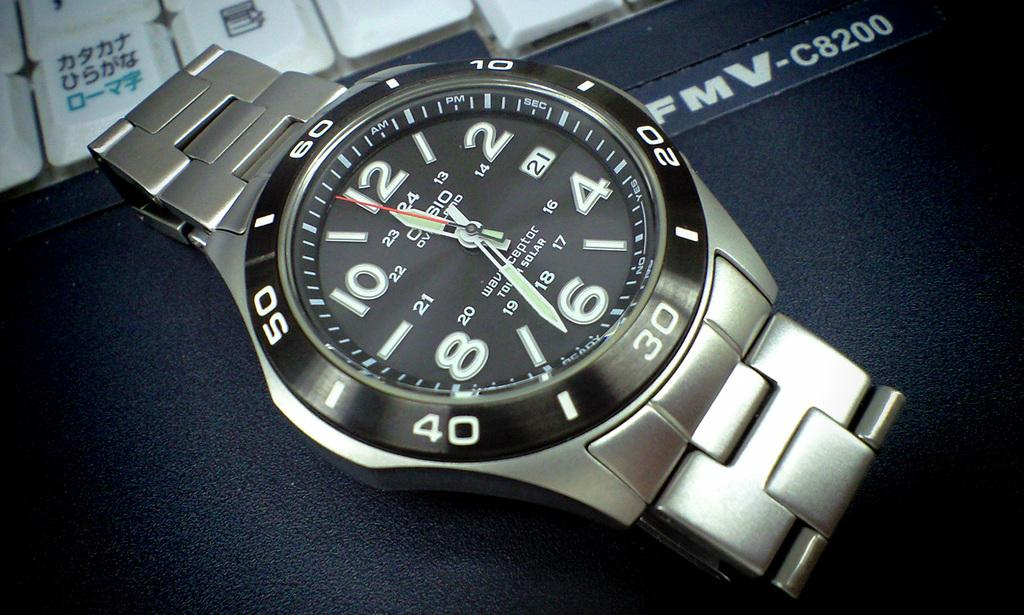Provide a one-sentence caption for the provided image. A silver watch with the hands on the face at 11:33. 